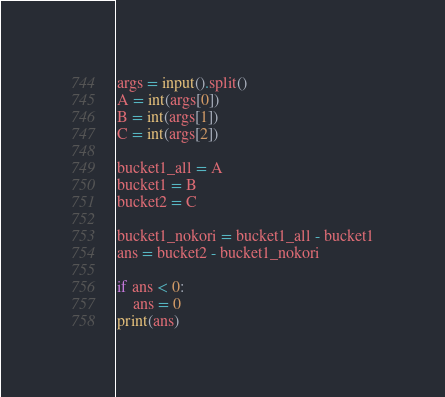<code> <loc_0><loc_0><loc_500><loc_500><_Python_>args = input().split()
A = int(args[0])
B = int(args[1])
C = int(args[2])

bucket1_all = A
bucket1 = B
bucket2 = C

bucket1_nokori = bucket1_all - bucket1
ans = bucket2 - bucket1_nokori

if ans < 0:
    ans = 0
print(ans)</code> 